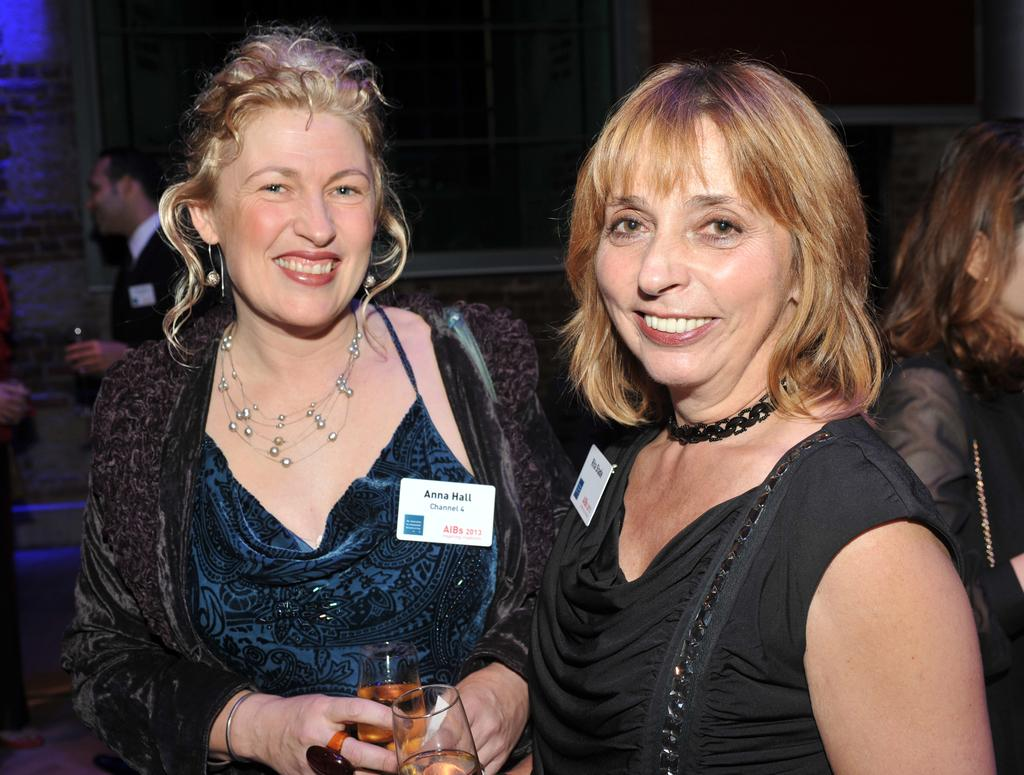How many women are in the image? There are 2 women in the image. What are the women doing in the image? The women are standing and smiling. What are the women holding in the image? The women are holding a glass of drink. Are there any other people visible in the image? Yes, there are other people visible in the image. What type of van can be seen in the background of the image? There is no van present in the image. What joke are the women telling each other in the image? There is no indication of a joke being told in the image; the women are simply smiling. 